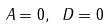Convert formula to latex. <formula><loc_0><loc_0><loc_500><loc_500>A = 0 , \ D = 0</formula> 